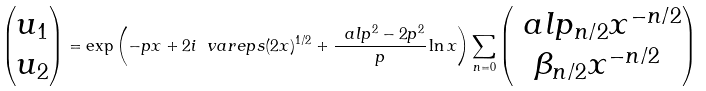Convert formula to latex. <formula><loc_0><loc_0><loc_500><loc_500>\begin{pmatrix} u _ { 1 } \\ u _ { 2 } \end{pmatrix} = \exp \left ( - p x + 2 i \ v a r e p s ( 2 x ) ^ { 1 / 2 } + \frac { \ a l p ^ { 2 } - 2 p ^ { 2 } } { p } \ln x \right ) \sum _ { n = 0 } \begin{pmatrix} \ a l p _ { n / 2 } x ^ { - n / 2 } \\ \beta _ { n / 2 } x ^ { - n / 2 } \end{pmatrix}</formula> 